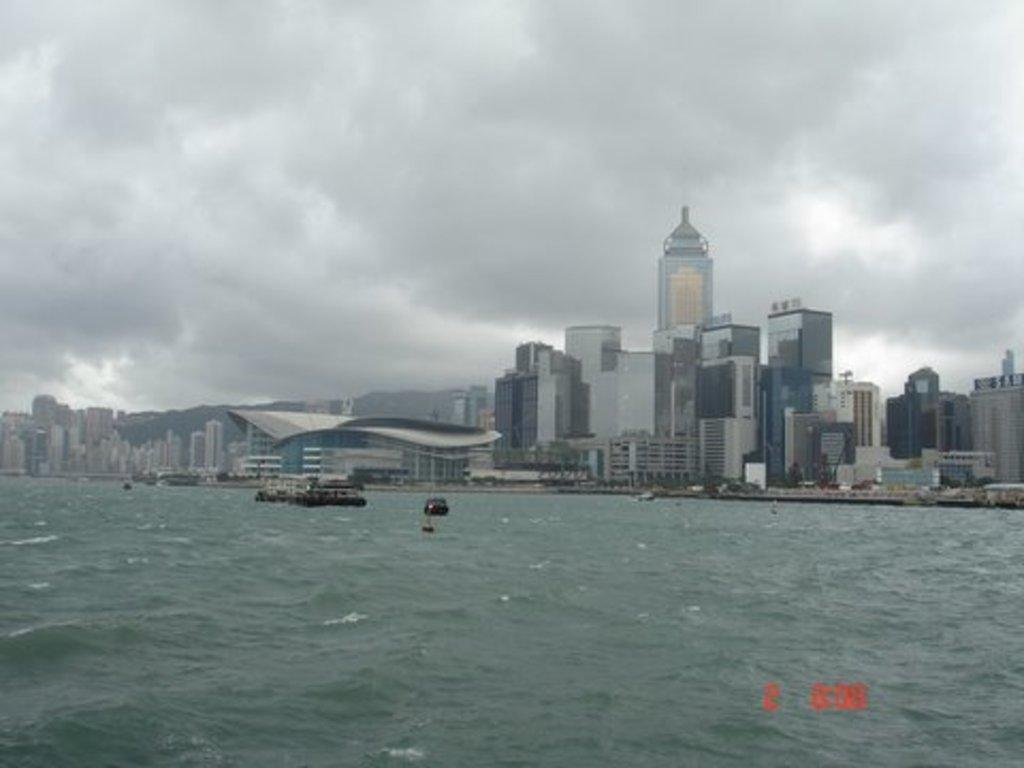What is in the water in the image? There are ships in the water in the image. What can be seen in the background of the image? There are buildings and trees in the background of the image. What is visible at the top of the image? The sky is visible at the top of the image. How many pies can be seen on the ships in the image? There are no pies present on the ships in the image. What type of ear is visible on the buildings in the background? There are no ears visible on the buildings in the background; they are simply structures. 